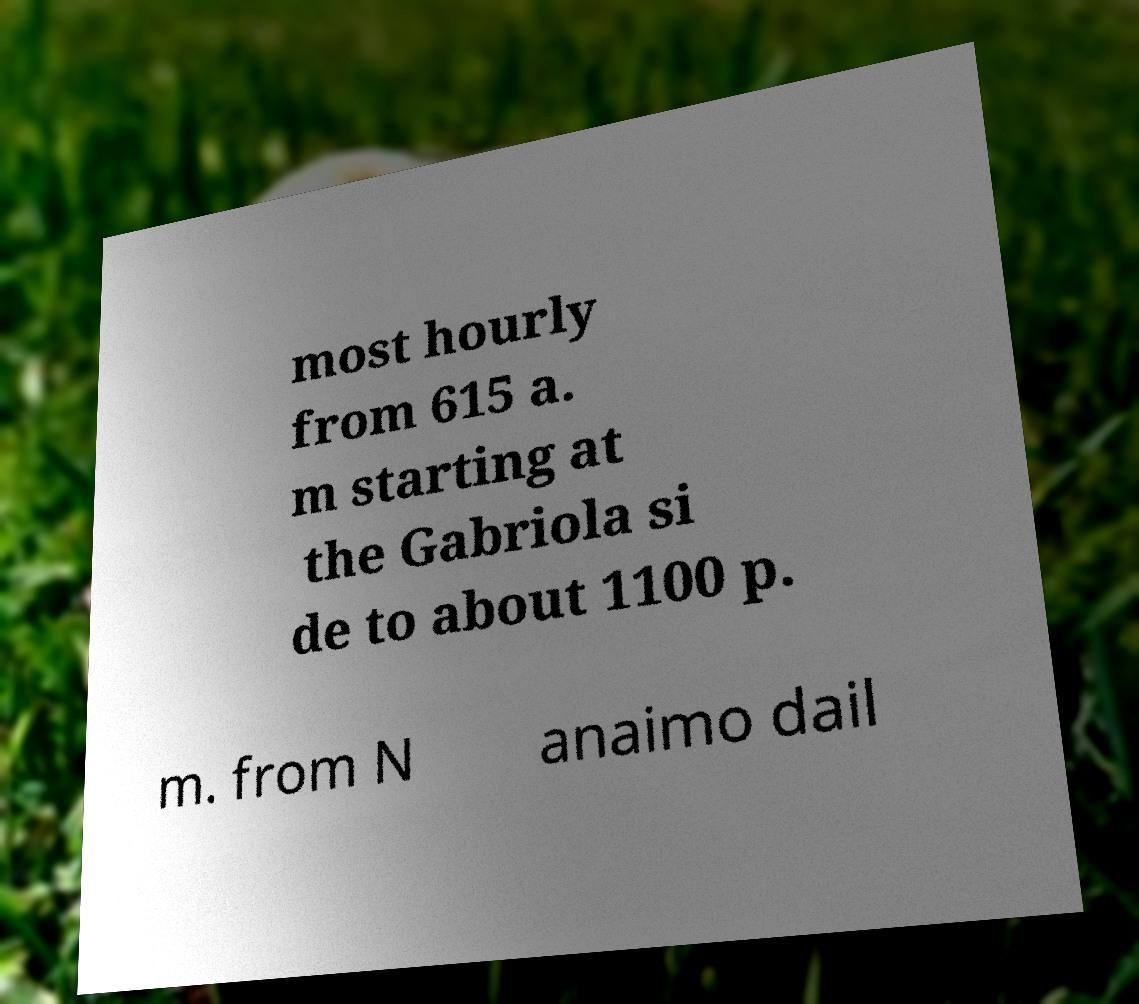Can you accurately transcribe the text from the provided image for me? most hourly from 615 a. m starting at the Gabriola si de to about 1100 p. m. from N anaimo dail 